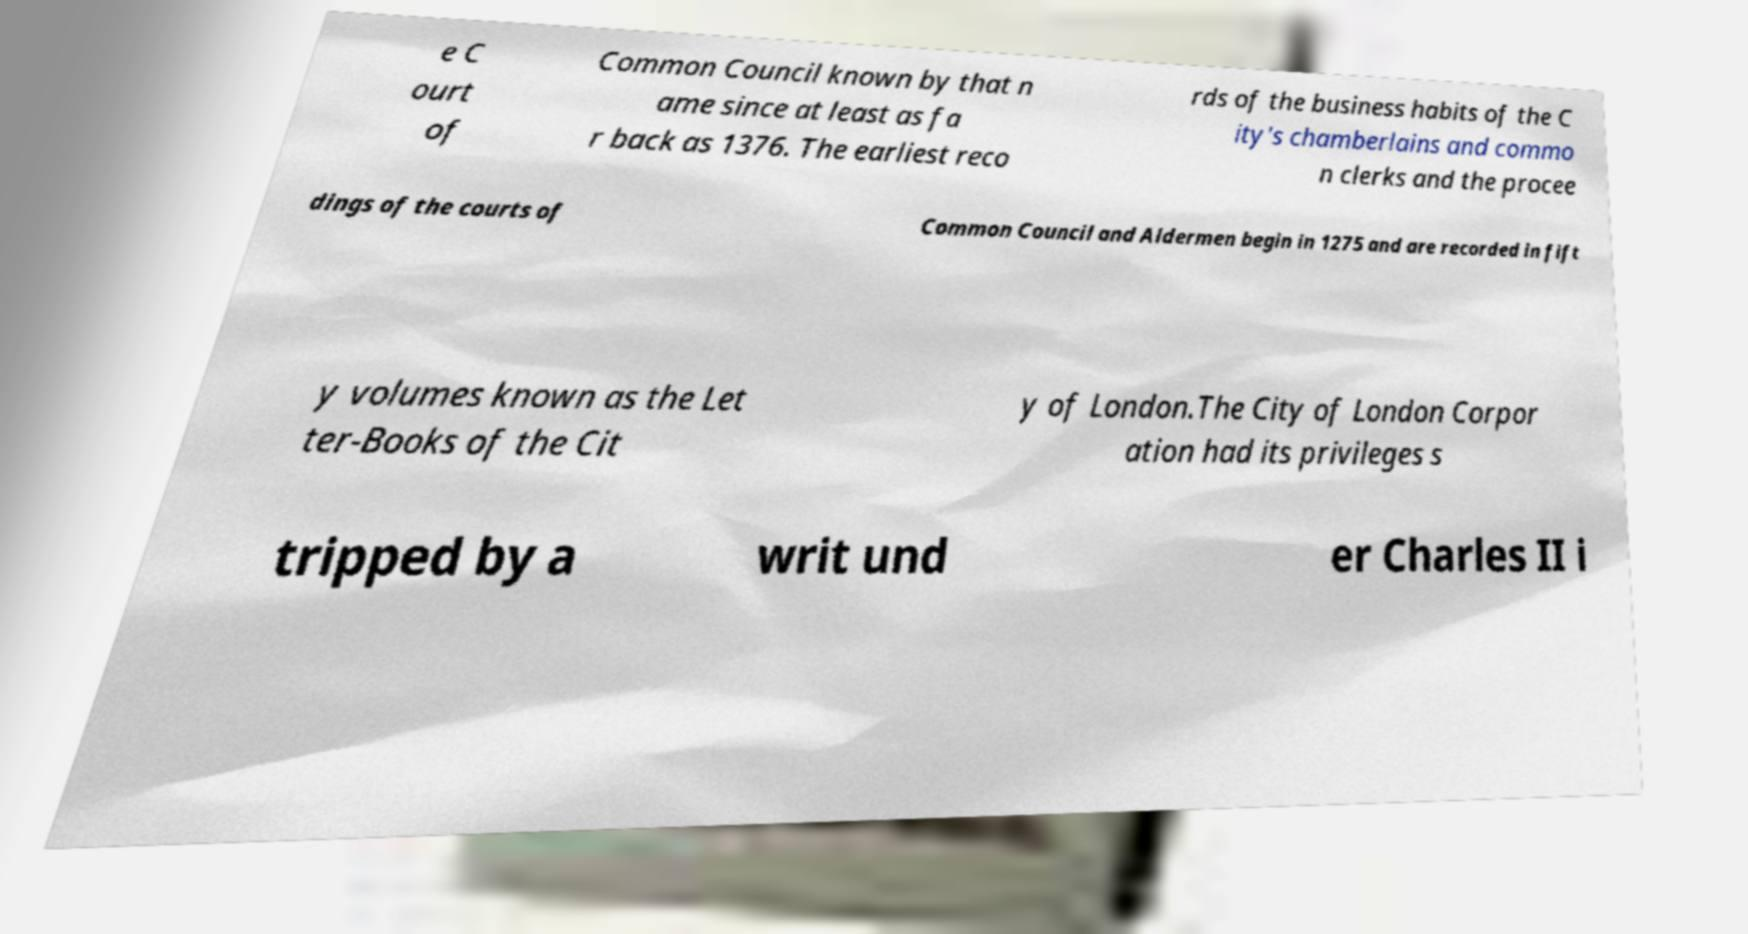Can you accurately transcribe the text from the provided image for me? e C ourt of Common Council known by that n ame since at least as fa r back as 1376. The earliest reco rds of the business habits of the C ity's chamberlains and commo n clerks and the procee dings of the courts of Common Council and Aldermen begin in 1275 and are recorded in fift y volumes known as the Let ter-Books of the Cit y of London.The City of London Corpor ation had its privileges s tripped by a writ und er Charles II i 